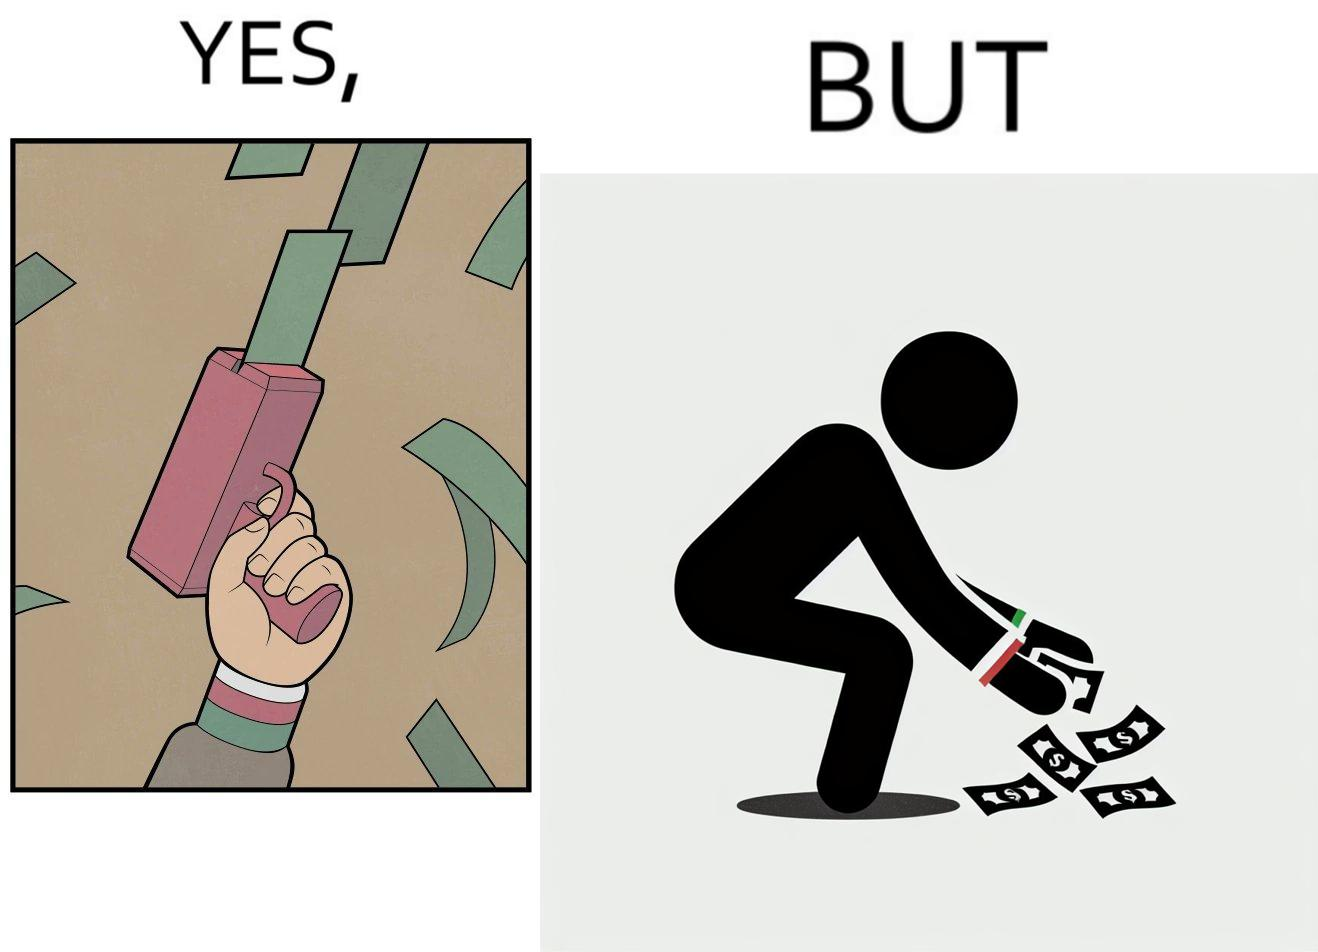Compare the left and right sides of this image. In the left part of the image: The image shows a hand holding a gun like object that is shooting out money bills in the air. The man's cuffs are green,red and white. In the right part of the image: The image showns a man crouching down to pick up fallen money bills on the ground. The man's cuffs are green, red and white. 